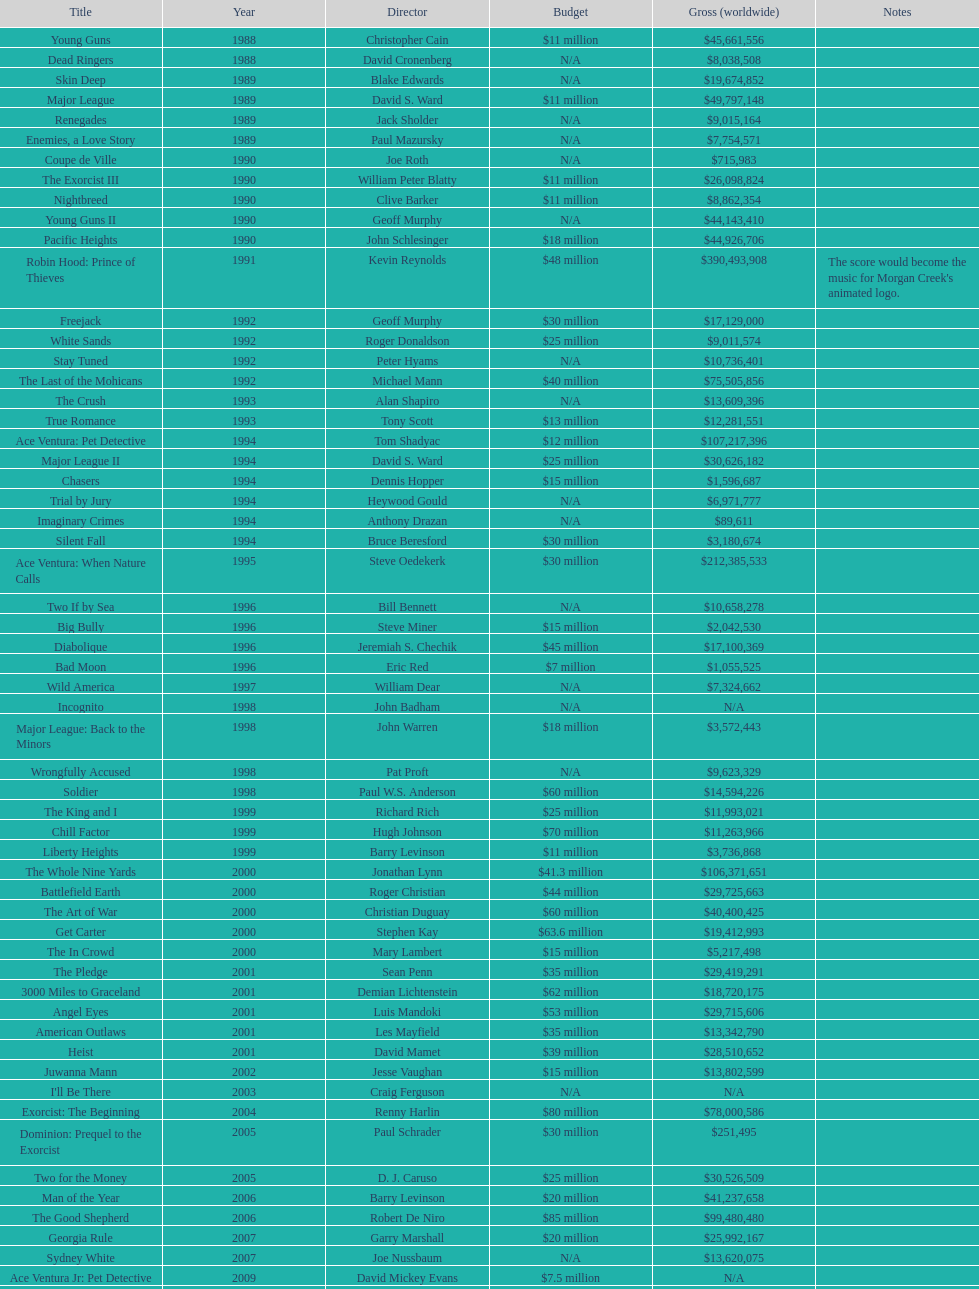Prior to 1994, which morgan creek movie had the highest earnings? Robin Hood: Prince of Thieves. Parse the table in full. {'header': ['Title', 'Year', 'Director', 'Budget', 'Gross (worldwide)', 'Notes'], 'rows': [['Young Guns', '1988', 'Christopher Cain', '$11 million', '$45,661,556', ''], ['Dead Ringers', '1988', 'David Cronenberg', 'N/A', '$8,038,508', ''], ['Skin Deep', '1989', 'Blake Edwards', 'N/A', '$19,674,852', ''], ['Major League', '1989', 'David S. Ward', '$11 million', '$49,797,148', ''], ['Renegades', '1989', 'Jack Sholder', 'N/A', '$9,015,164', ''], ['Enemies, a Love Story', '1989', 'Paul Mazursky', 'N/A', '$7,754,571', ''], ['Coupe de Ville', '1990', 'Joe Roth', 'N/A', '$715,983', ''], ['The Exorcist III', '1990', 'William Peter Blatty', '$11 million', '$26,098,824', ''], ['Nightbreed', '1990', 'Clive Barker', '$11 million', '$8,862,354', ''], ['Young Guns II', '1990', 'Geoff Murphy', 'N/A', '$44,143,410', ''], ['Pacific Heights', '1990', 'John Schlesinger', '$18 million', '$44,926,706', ''], ['Robin Hood: Prince of Thieves', '1991', 'Kevin Reynolds', '$48 million', '$390,493,908', "The score would become the music for Morgan Creek's animated logo."], ['Freejack', '1992', 'Geoff Murphy', '$30 million', '$17,129,000', ''], ['White Sands', '1992', 'Roger Donaldson', '$25 million', '$9,011,574', ''], ['Stay Tuned', '1992', 'Peter Hyams', 'N/A', '$10,736,401', ''], ['The Last of the Mohicans', '1992', 'Michael Mann', '$40 million', '$75,505,856', ''], ['The Crush', '1993', 'Alan Shapiro', 'N/A', '$13,609,396', ''], ['True Romance', '1993', 'Tony Scott', '$13 million', '$12,281,551', ''], ['Ace Ventura: Pet Detective', '1994', 'Tom Shadyac', '$12 million', '$107,217,396', ''], ['Major League II', '1994', 'David S. Ward', '$25 million', '$30,626,182', ''], ['Chasers', '1994', 'Dennis Hopper', '$15 million', '$1,596,687', ''], ['Trial by Jury', '1994', 'Heywood Gould', 'N/A', '$6,971,777', ''], ['Imaginary Crimes', '1994', 'Anthony Drazan', 'N/A', '$89,611', ''], ['Silent Fall', '1994', 'Bruce Beresford', '$30 million', '$3,180,674', ''], ['Ace Ventura: When Nature Calls', '1995', 'Steve Oedekerk', '$30 million', '$212,385,533', ''], ['Two If by Sea', '1996', 'Bill Bennett', 'N/A', '$10,658,278', ''], ['Big Bully', '1996', 'Steve Miner', '$15 million', '$2,042,530', ''], ['Diabolique', '1996', 'Jeremiah S. Chechik', '$45 million', '$17,100,369', ''], ['Bad Moon', '1996', 'Eric Red', '$7 million', '$1,055,525', ''], ['Wild America', '1997', 'William Dear', 'N/A', '$7,324,662', ''], ['Incognito', '1998', 'John Badham', 'N/A', 'N/A', ''], ['Major League: Back to the Minors', '1998', 'John Warren', '$18 million', '$3,572,443', ''], ['Wrongfully Accused', '1998', 'Pat Proft', 'N/A', '$9,623,329', ''], ['Soldier', '1998', 'Paul W.S. Anderson', '$60 million', '$14,594,226', ''], ['The King and I', '1999', 'Richard Rich', '$25 million', '$11,993,021', ''], ['Chill Factor', '1999', 'Hugh Johnson', '$70 million', '$11,263,966', ''], ['Liberty Heights', '1999', 'Barry Levinson', '$11 million', '$3,736,868', ''], ['The Whole Nine Yards', '2000', 'Jonathan Lynn', '$41.3 million', '$106,371,651', ''], ['Battlefield Earth', '2000', 'Roger Christian', '$44 million', '$29,725,663', ''], ['The Art of War', '2000', 'Christian Duguay', '$60 million', '$40,400,425', ''], ['Get Carter', '2000', 'Stephen Kay', '$63.6 million', '$19,412,993', ''], ['The In Crowd', '2000', 'Mary Lambert', '$15 million', '$5,217,498', ''], ['The Pledge', '2001', 'Sean Penn', '$35 million', '$29,419,291', ''], ['3000 Miles to Graceland', '2001', 'Demian Lichtenstein', '$62 million', '$18,720,175', ''], ['Angel Eyes', '2001', 'Luis Mandoki', '$53 million', '$29,715,606', ''], ['American Outlaws', '2001', 'Les Mayfield', '$35 million', '$13,342,790', ''], ['Heist', '2001', 'David Mamet', '$39 million', '$28,510,652', ''], ['Juwanna Mann', '2002', 'Jesse Vaughan', '$15 million', '$13,802,599', ''], ["I'll Be There", '2003', 'Craig Ferguson', 'N/A', 'N/A', ''], ['Exorcist: The Beginning', '2004', 'Renny Harlin', '$80 million', '$78,000,586', ''], ['Dominion: Prequel to the Exorcist', '2005', 'Paul Schrader', '$30 million', '$251,495', ''], ['Two for the Money', '2005', 'D. J. Caruso', '$25 million', '$30,526,509', ''], ['Man of the Year', '2006', 'Barry Levinson', '$20 million', '$41,237,658', ''], ['The Good Shepherd', '2006', 'Robert De Niro', '$85 million', '$99,480,480', ''], ['Georgia Rule', '2007', 'Garry Marshall', '$20 million', '$25,992,167', ''], ['Sydney White', '2007', 'Joe Nussbaum', 'N/A', '$13,620,075', ''], ['Ace Ventura Jr: Pet Detective', '2009', 'David Mickey Evans', '$7.5 million', 'N/A', ''], ['Dream House', '2011', 'Jim Sheridan', '$50 million', '$38,502,340', ''], ['The Thing', '2011', 'Matthijs van Heijningen Jr.', '$38 million', '$27,428,670', ''], ['Tupac', '2014', 'Antoine Fuqua', '$45 million', '', '']]} 